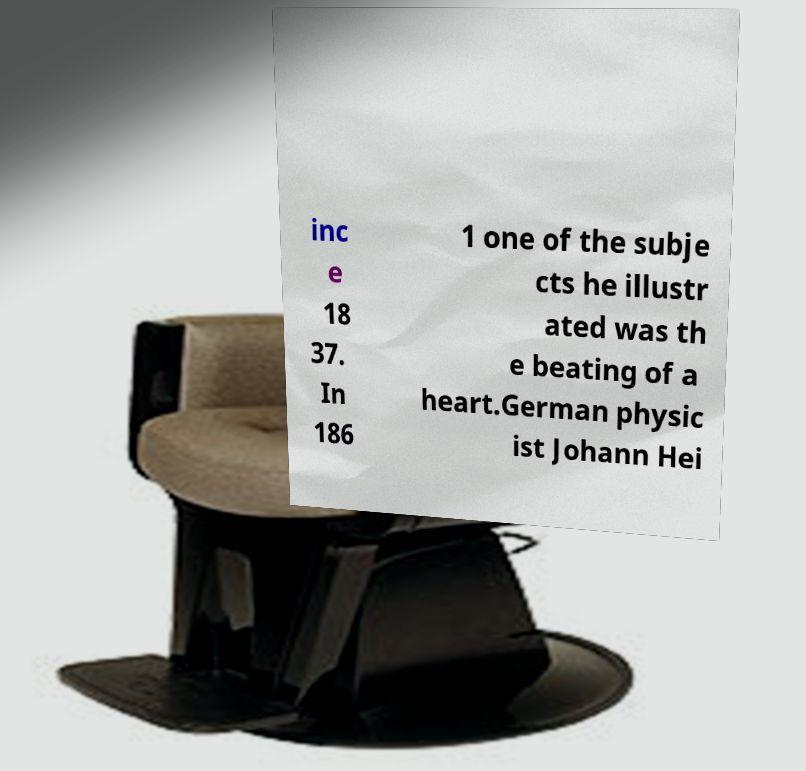Could you extract and type out the text from this image? inc e 18 37. In 186 1 one of the subje cts he illustr ated was th e beating of a heart.German physic ist Johann Hei 